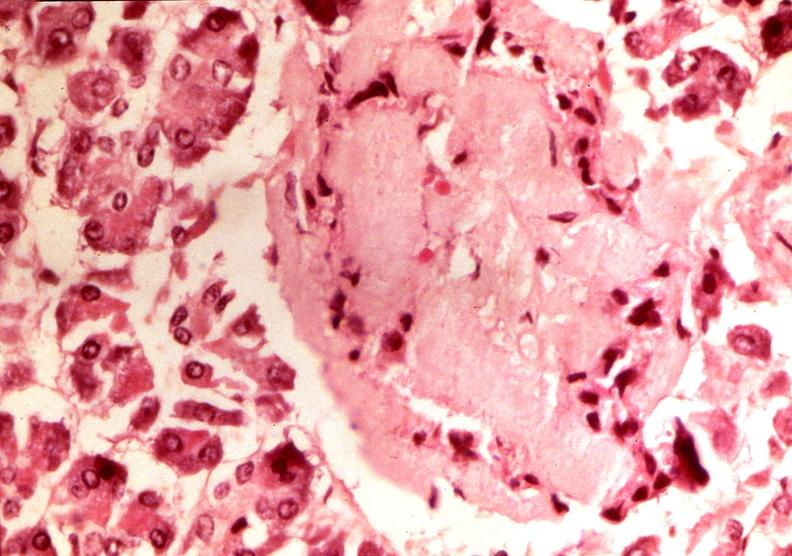does abdomen show pancrease, islet amyloid, diabetes mellitus?
Answer the question using a single word or phrase. No 